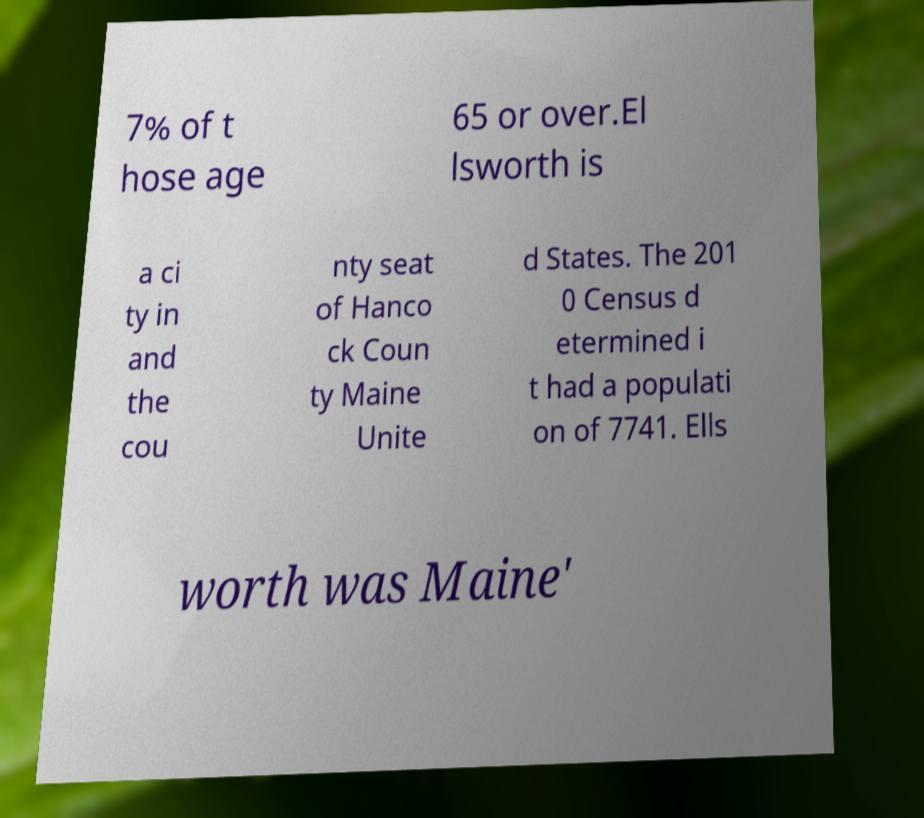Can you read and provide the text displayed in the image?This photo seems to have some interesting text. Can you extract and type it out for me? 7% of t hose age 65 or over.El lsworth is a ci ty in and the cou nty seat of Hanco ck Coun ty Maine Unite d States. The 201 0 Census d etermined i t had a populati on of 7741. Ells worth was Maine' 